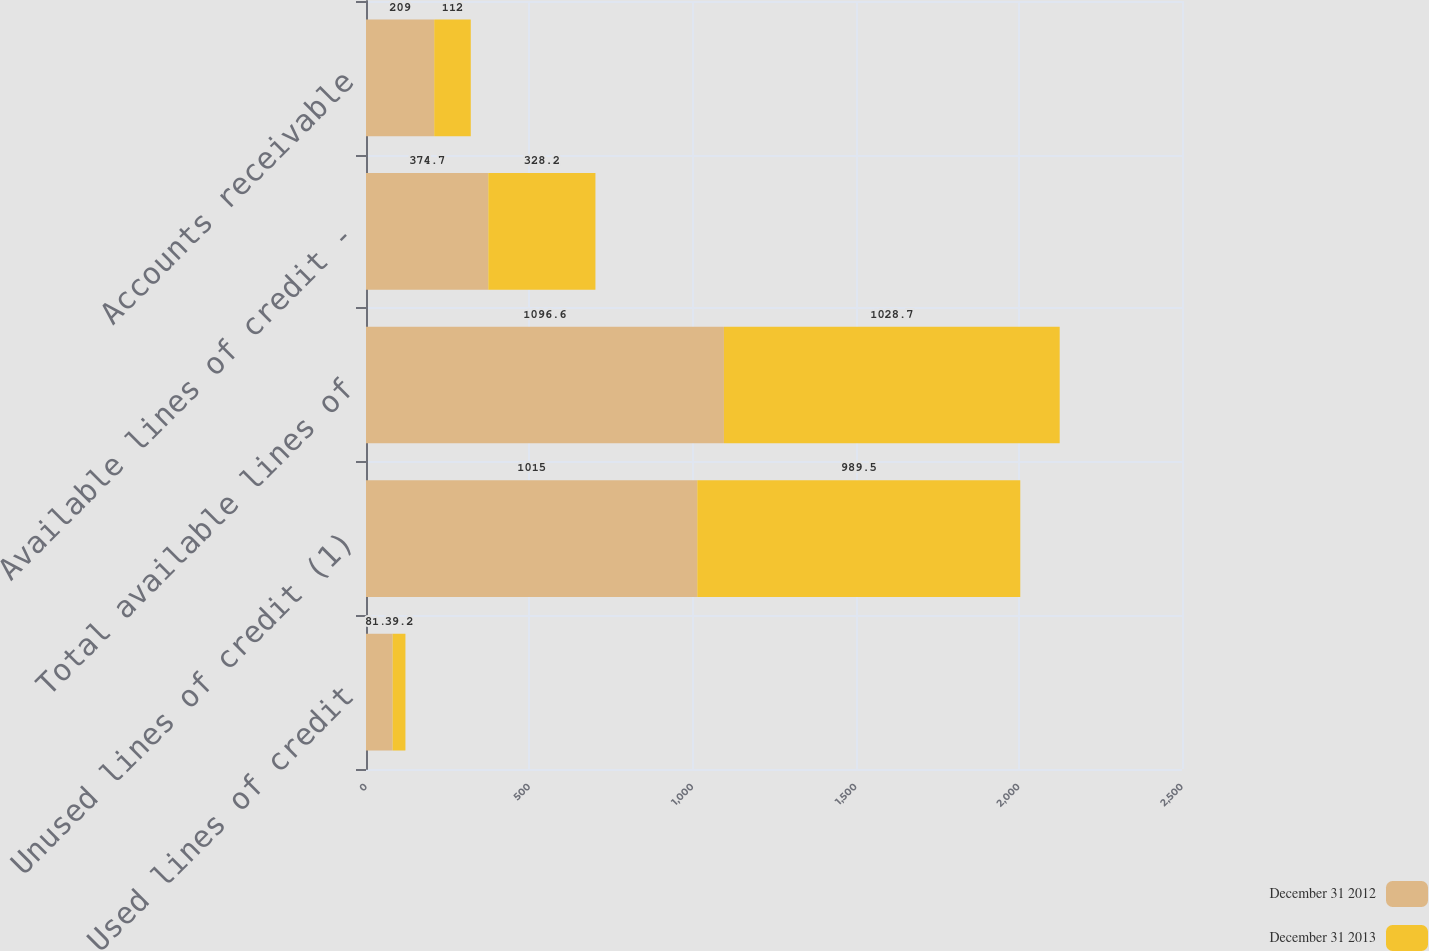<chart> <loc_0><loc_0><loc_500><loc_500><stacked_bar_chart><ecel><fcel>Used lines of credit<fcel>Unused lines of credit (1)<fcel>Total available lines of<fcel>Available lines of credit -<fcel>Accounts receivable<nl><fcel>December 31 2012<fcel>81.6<fcel>1015<fcel>1096.6<fcel>374.7<fcel>209<nl><fcel>December 31 2013<fcel>39.2<fcel>989.5<fcel>1028.7<fcel>328.2<fcel>112<nl></chart> 